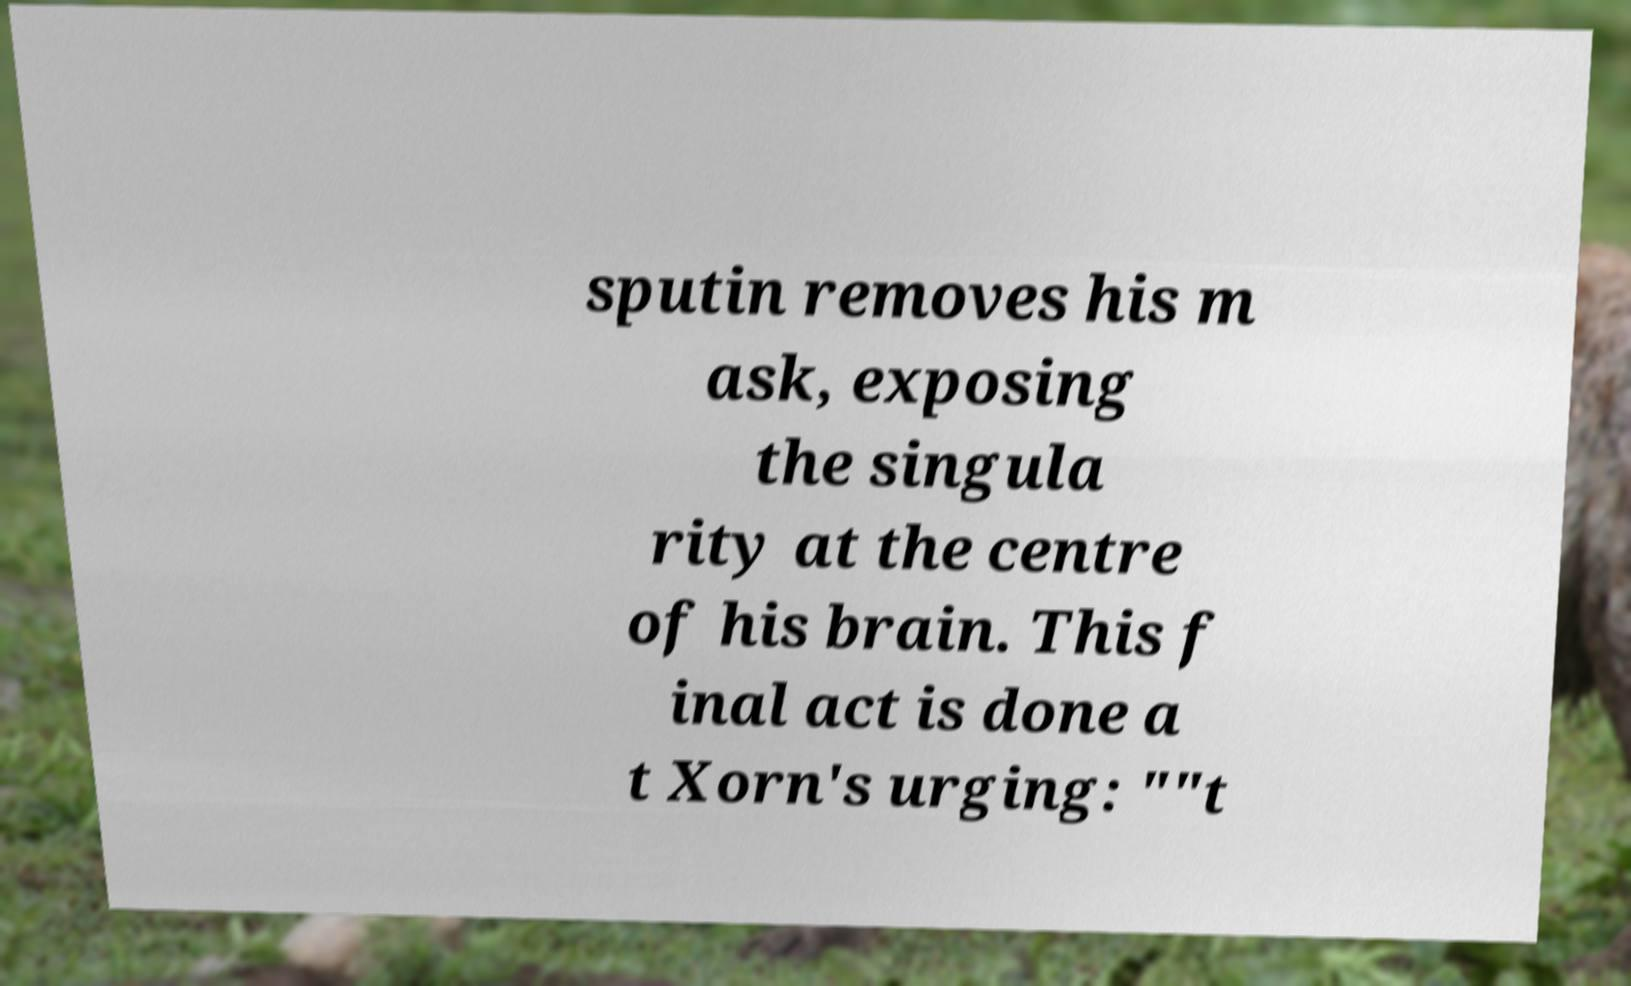Could you assist in decoding the text presented in this image and type it out clearly? sputin removes his m ask, exposing the singula rity at the centre of his brain. This f inal act is done a t Xorn's urging: ""t 